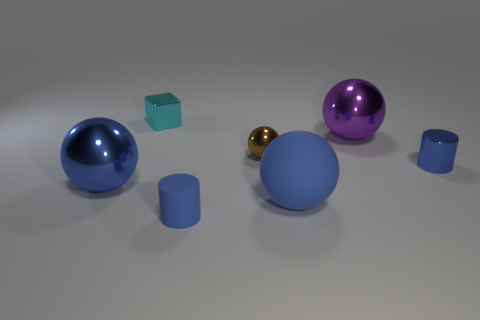Subtract all gray cylinders. How many blue spheres are left? 2 Subtract all blue shiny balls. How many balls are left? 3 Subtract all purple balls. How many balls are left? 3 Subtract 2 spheres. How many spheres are left? 2 Add 2 shiny balls. How many objects exist? 9 Subtract all cylinders. How many objects are left? 5 Subtract all yellow spheres. Subtract all cyan cubes. How many spheres are left? 4 Add 3 large metal spheres. How many large metal spheres are left? 5 Add 3 small objects. How many small objects exist? 7 Subtract 0 purple blocks. How many objects are left? 7 